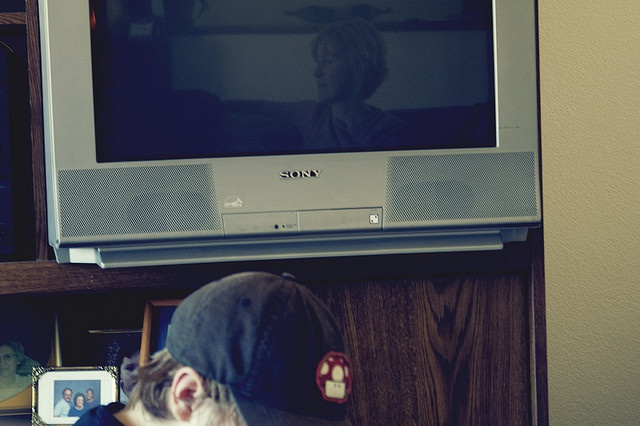Describe the objects in this image and their specific colors. I can see tv in black, navy, darkgray, and gray tones, people in black, navy, gray, and darkblue tones, and people in black, navy, and gray tones in this image. 